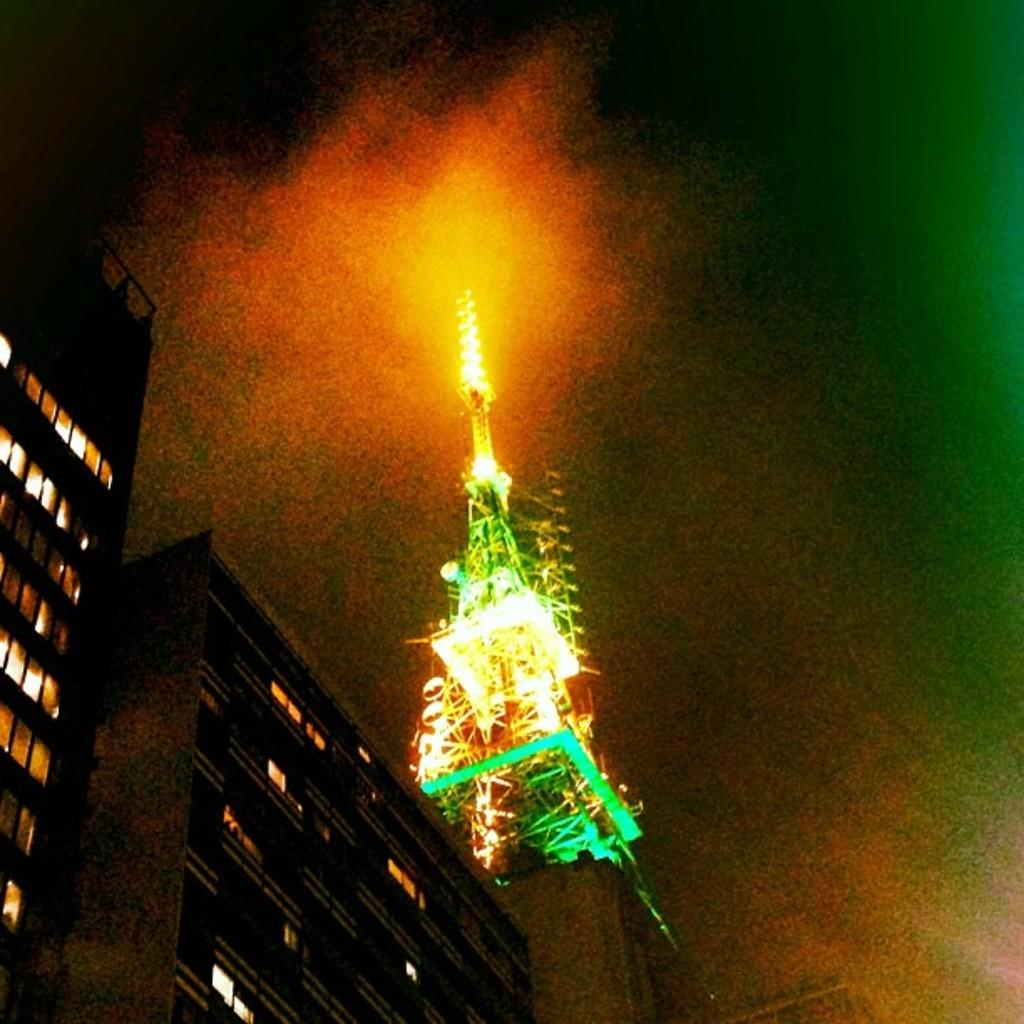What is the main structure in the image? There is a tower in the image. What feature does the tower have? The tower has lighting. What type of structures can be seen in the image besides the tower? There are buildings with windows in the image. What is the likely setting of the image? The image likely depicts a sky. What type of country is depicted in the image? The image does not depict a country; it shows a tower, buildings, and a sky. What is the temperature of the roof in the image? There is no roof present in the image, so it is not possible to determine the temperature. 